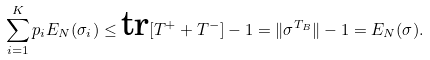Convert formula to latex. <formula><loc_0><loc_0><loc_500><loc_500>\sum _ { i = 1 } ^ { K } p _ { i } E _ { N } ( \sigma _ { i } ) \leq { \text {tr} } [ T ^ { + } + T ^ { - } ] - 1 = \| \sigma ^ { T _ { B } } \| - 1 = E _ { N } ( \sigma ) .</formula> 